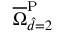Convert formula to latex. <formula><loc_0><loc_0><loc_500><loc_500>\overline { \Omega } _ { \hat { d } = 2 } ^ { P }</formula> 